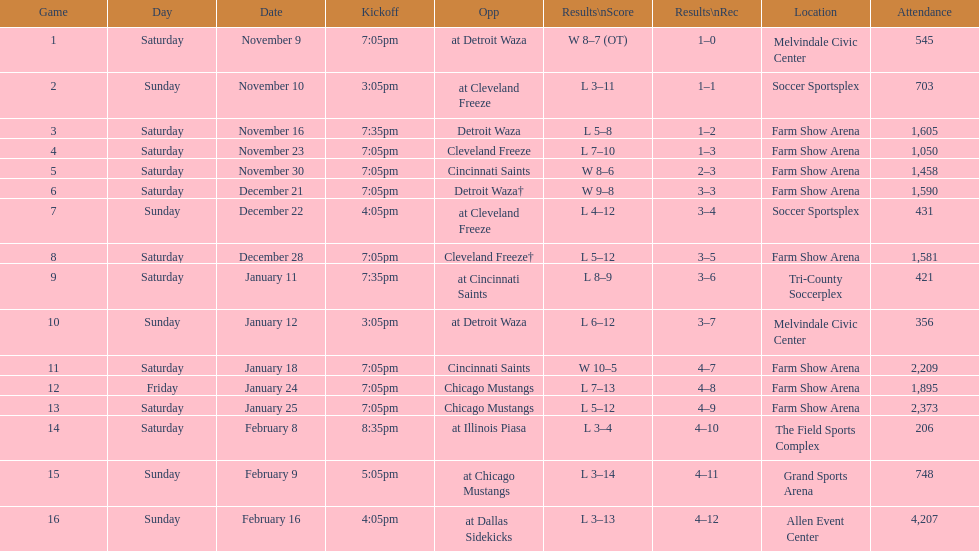How many games did the harrisburg heat win in which they scored eight or more goals? 4. 